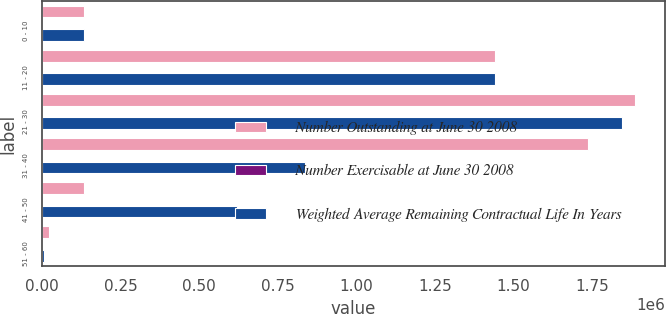<chart> <loc_0><loc_0><loc_500><loc_500><stacked_bar_chart><ecel><fcel>0 - 10<fcel>11 - 20<fcel>21 - 30<fcel>31 - 40<fcel>41 - 50<fcel>51 - 60<nl><fcel>Number Outstanding at June 30 2008<fcel>133895<fcel>1.441e+06<fcel>1.88786e+06<fcel>1.73649e+06<fcel>133895<fcel>24000<nl><fcel>Number Exercisable at June 30 2008<fcel>1.06<fcel>4.25<fcel>5.25<fcel>7.39<fcel>5.99<fcel>5.68<nl><fcel>Weighted Average Remaining Contractual Life In Years<fcel>133895<fcel>1.441e+06<fcel>1.84546e+06<fcel>838331<fcel>620427<fcel>5375<nl></chart> 